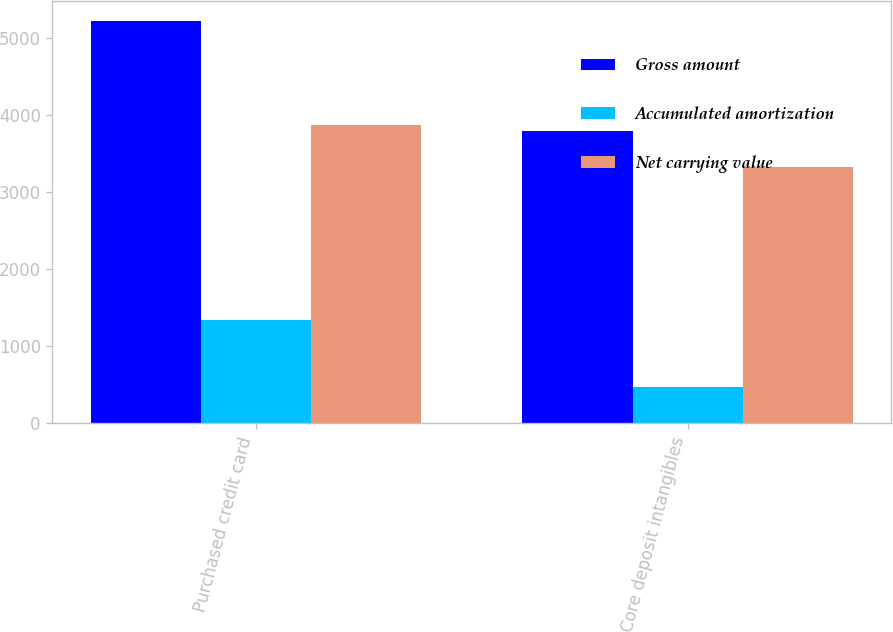Convert chart to OTSL. <chart><loc_0><loc_0><loc_500><loc_500><stacked_bar_chart><ecel><fcel>Purchased credit card<fcel>Core deposit intangibles<nl><fcel>Gross amount<fcel>5225<fcel>3797<nl><fcel>Accumulated amortization<fcel>1347<fcel>469<nl><fcel>Net carrying value<fcel>3878<fcel>3328<nl></chart> 